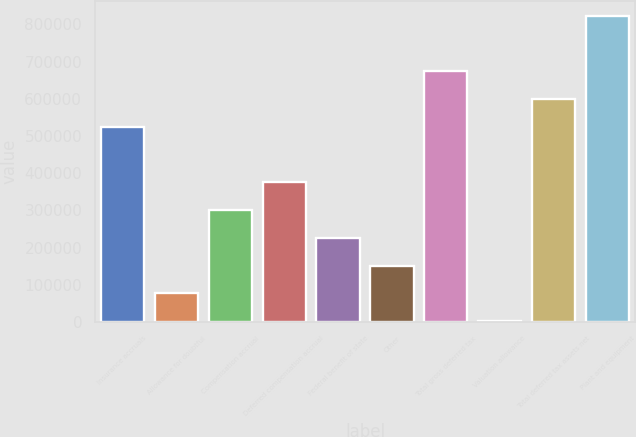<chart> <loc_0><loc_0><loc_500><loc_500><bar_chart><fcel>Insurance accruals<fcel>Allowance for doubtful<fcel>Compensation accrual<fcel>Deferred compensation accrual<fcel>Federal benefit of state<fcel>Other<fcel>Total gross deferred tax<fcel>Valuation allowance<fcel>Total deferred tax assets net<fcel>Plant and equipment<nl><fcel>524634<fcel>76656.8<fcel>300645<fcel>375308<fcel>225982<fcel>151320<fcel>673959<fcel>1994<fcel>599296<fcel>823285<nl></chart> 